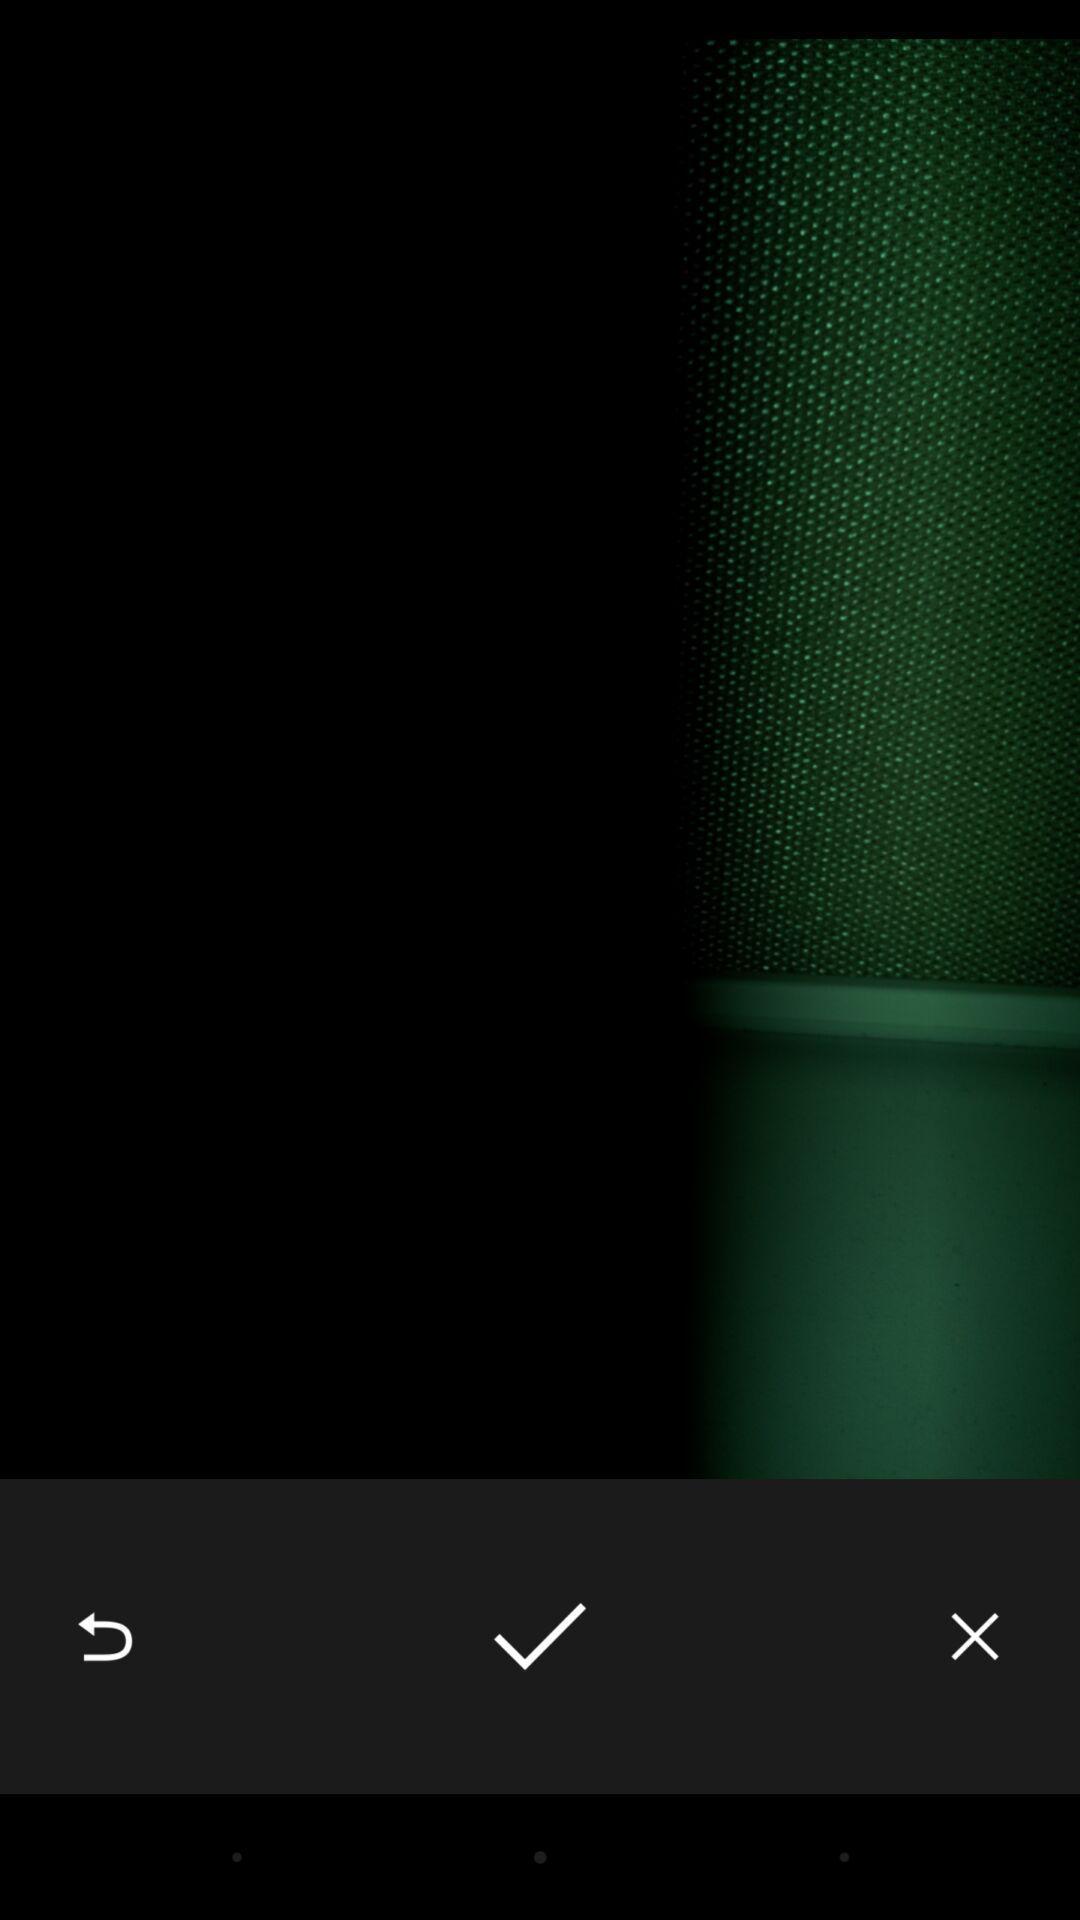Summarize the information in this screenshot. Photo in a camera app. 